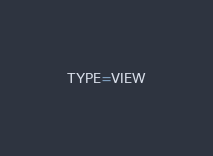Convert code to text. <code><loc_0><loc_0><loc_500><loc_500><_VisualBasic_>TYPE=VIEW</code> 